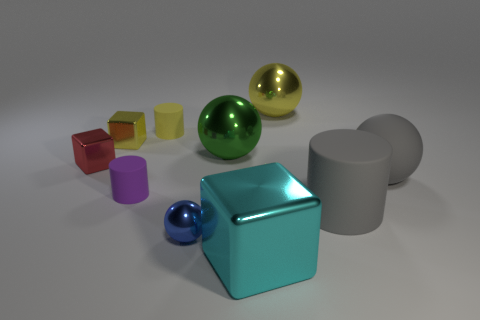Is the small blue thing on the left side of the cyan cube made of the same material as the yellow cylinder?
Give a very brief answer. No. How many objects are either cyan metallic cubes or metal balls that are in front of the tiny red object?
Your answer should be compact. 2. What color is the ball that is made of the same material as the large cylinder?
Your answer should be compact. Gray. What number of big yellow spheres are the same material as the large cylinder?
Provide a short and direct response. 0. What number of large purple matte spheres are there?
Make the answer very short. 0. Does the cube that is in front of the red metal object have the same color as the small matte cylinder that is to the left of the yellow cylinder?
Ensure brevity in your answer.  No. There is a large yellow sphere; how many yellow balls are right of it?
Your response must be concise. 0. What is the material of the large ball that is the same color as the large matte cylinder?
Provide a succinct answer. Rubber. Is there another red metal object of the same shape as the red metal object?
Provide a succinct answer. No. Does the small thing right of the small yellow cylinder have the same material as the tiny red thing left of the tiny yellow metallic thing?
Provide a succinct answer. Yes. 